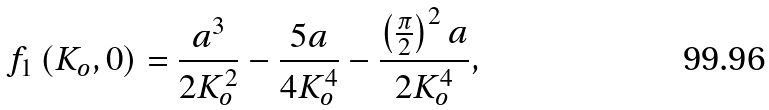Convert formula to latex. <formula><loc_0><loc_0><loc_500><loc_500>f _ { 1 } \left ( K _ { o } , 0 \right ) = \frac { a ^ { 3 } } { 2 K _ { o } ^ { 2 } } - \frac { 5 a } { 4 K _ { o } ^ { 4 } } - \frac { \left ( \frac { \pi } { 2 } \right ) ^ { 2 } a } { 2 K _ { o } ^ { 4 } } ,</formula> 